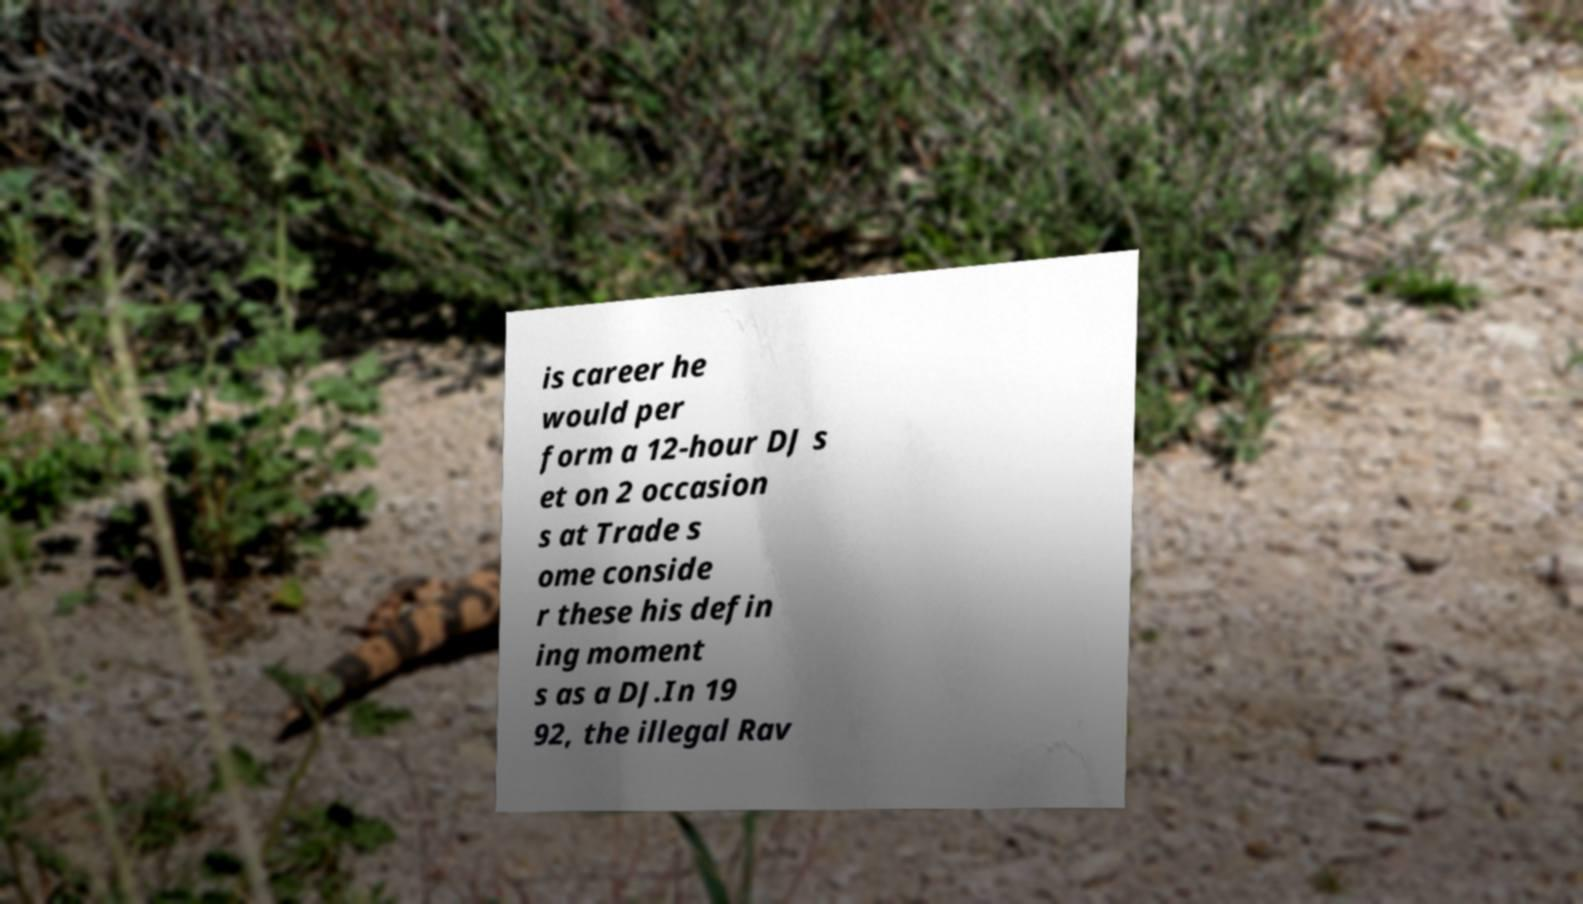Please identify and transcribe the text found in this image. is career he would per form a 12-hour DJ s et on 2 occasion s at Trade s ome conside r these his defin ing moment s as a DJ.In 19 92, the illegal Rav 